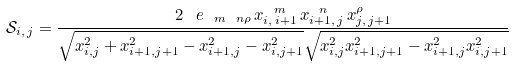Convert formula to latex. <formula><loc_0><loc_0><loc_500><loc_500>\mathcal { S } _ { i , \, j } = \frac { 2 \, \ e _ { \ m \ n \rho } \, x _ { i , \, i + 1 } ^ { \ m } \, x _ { i + 1 , \, j } ^ { \ n } \, x _ { j , \, j + 1 } ^ { \rho } } { \sqrt { x _ { i , j } ^ { 2 } + x _ { i + 1 , j + 1 } ^ { 2 } - x _ { i + 1 , j } ^ { 2 } - x _ { i , j + 1 } ^ { 2 } } \sqrt { x _ { i , j } ^ { 2 } x _ { i + 1 , j + 1 } ^ { 2 } - x _ { i + 1 , j } ^ { 2 } x _ { i , j + 1 } ^ { 2 } } }</formula> 